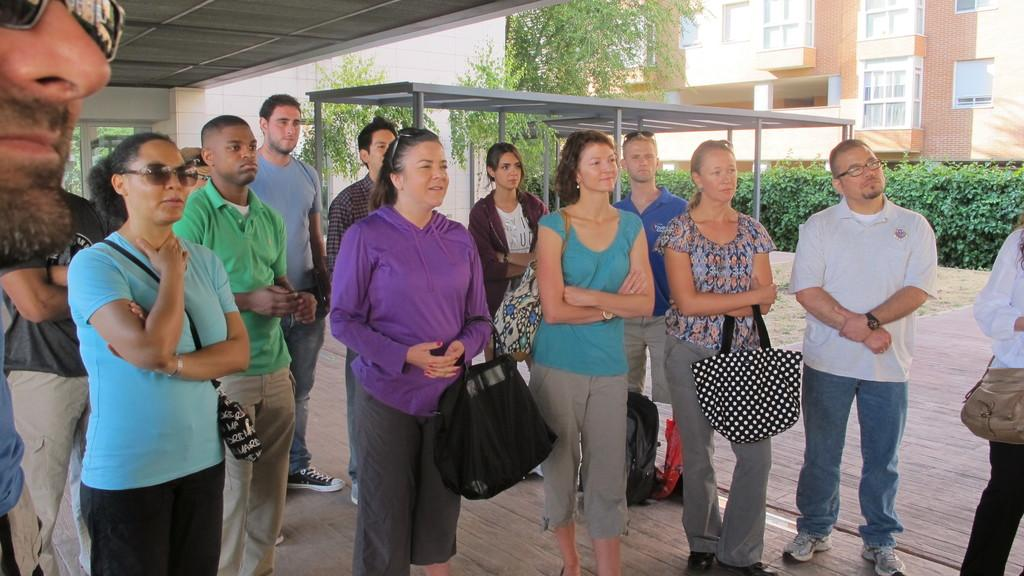How many people are in the image? There are many persons standing in the image. Where are the persons standing? The persons are standing on the floor. What can be seen beside the persons? There are bags beside the persons. What structures can be seen in the background of the image? There is a shed and a building visible in the background of the image. What type of vegetation is present in the background of the image? Trees and plants are visible in the background of the image. Can you see a tiger combing its sheet in the image? There is no tiger, comb, or sheet present in the image. 